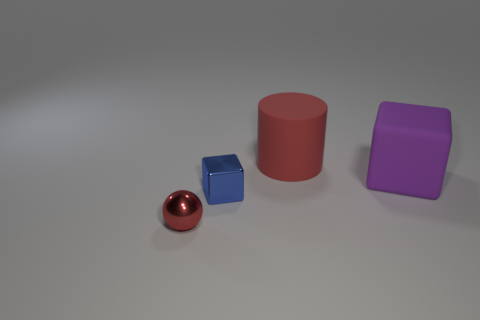Are there fewer large cylinders than small cyan balls?
Keep it short and to the point. No. There is a blue thing; is it the same shape as the metal thing to the left of the tiny blue shiny cube?
Offer a terse response. No. What shape is the thing that is to the left of the big cylinder and behind the shiny sphere?
Offer a terse response. Cube. Are there the same number of large matte cubes behind the tiny blue object and tiny red metal balls that are in front of the big red matte thing?
Make the answer very short. Yes. There is a tiny shiny object that is to the right of the small red object; does it have the same shape as the big red object?
Your answer should be very brief. No. What number of brown things are small cubes or small metallic things?
Give a very brief answer. 0. What material is the other object that is the same shape as the purple object?
Offer a very short reply. Metal. There is a red thing left of the small blue cube; what shape is it?
Give a very brief answer. Sphere. Is there another big blue cylinder that has the same material as the large cylinder?
Offer a very short reply. No. Is the size of the purple thing the same as the red rubber cylinder?
Give a very brief answer. Yes. 